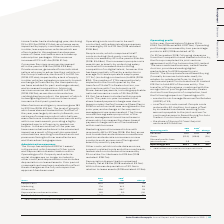According to Auto Trader's financial document, What are the total administrative expenses in 2019? According to the financial document, £112.3m. The relevant text states: ", with administrative expenses increasing by 3% to £112.3m (2018 restated: £108.8m)...." Also, What are Marketing costs in 2019? According to the financial document, £17.6m. The relevant text states: "ting spend increased in line with revenue by 8% to £17.6m (2018: £16.3m), as we look to maintain and enhance our audience position and educate consumers on ne..." Also, What are the components factored in when calculating the total administrative expenses? The document contains multiple relevant values: People costs, Marketing, Other costs, Depreciation and amortisation. From the document: "People costs 56.4 54.8 3% Marketing 17.6 16.3 8% Depreciation and amortisation 8.9 9.0 (1%) Other costs 29.4 28.7 2%..." Additionally, In which year was Depreciation and amortisation larger? According to the financial document, 2018. The relevant text states: "Costs 2019 £m 2018 1 £m Change..." Also, can you calculate: What was the change in Other costs in 2019 from 2018? Based on the calculation: 29.4-28.7, the result is 0.7 (in millions). This is based on the information: "Other costs 29.4 28.7 2% Other costs 29.4 28.7 2%..." The key data points involved are: 28.7, 29.4. Also, can you calculate: What was the average Total administrative expenses in 2018 and 2019? To answer this question, I need to perform calculations using the financial data. The calculation is: (112.3+108.8)/2, which equals 110.55 (in millions). This is based on the information: "Total administrative expenses 112.3 108.8 3% Total administrative expenses 112.3 108.8 3%..." The key data points involved are: 108.8, 112.3. 